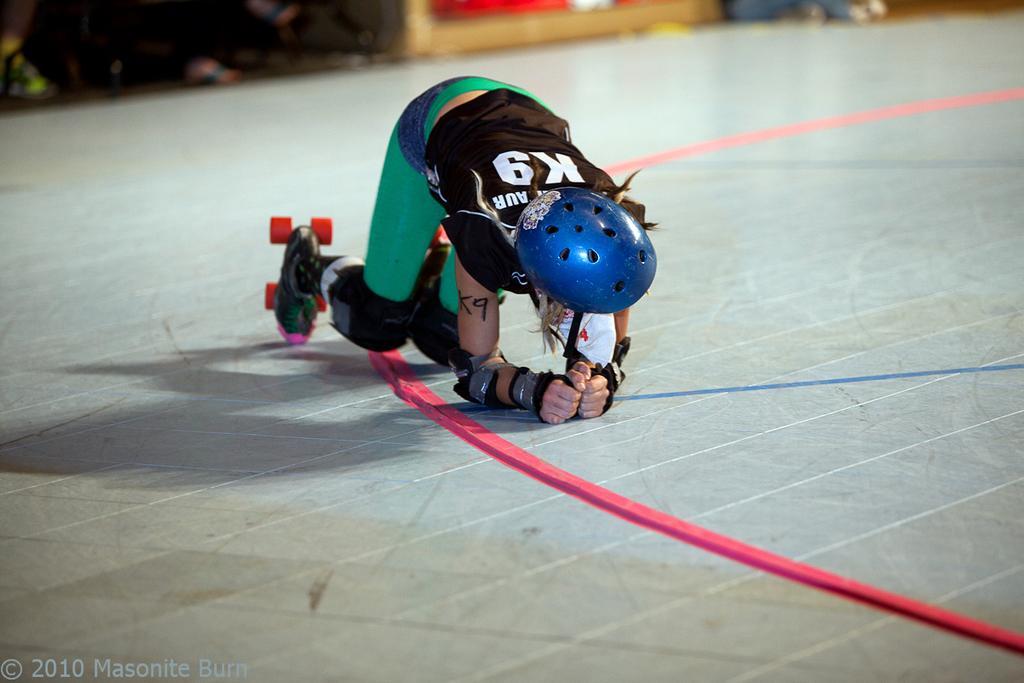Please provide a concise description of this image. In this image there is a person wearing skating shoes is kneeled down on the skating track with markings. In the background of the image we can see the legs of a people. There is some text at the bottom of the image. 